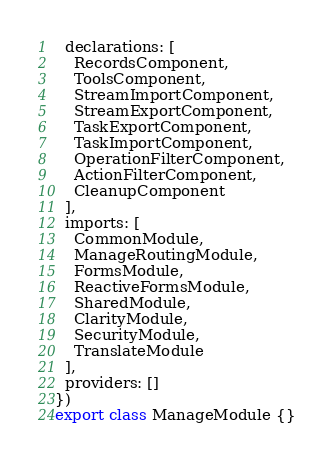Convert code to text. <code><loc_0><loc_0><loc_500><loc_500><_TypeScript_>  declarations: [
    RecordsComponent,
    ToolsComponent,
    StreamImportComponent,
    StreamExportComponent,
    TaskExportComponent,
    TaskImportComponent,
    OperationFilterComponent,
    ActionFilterComponent,
    CleanupComponent
  ],
  imports: [
    CommonModule,
    ManageRoutingModule,
    FormsModule,
    ReactiveFormsModule,
    SharedModule,
    ClarityModule,
    SecurityModule,
    TranslateModule
  ],
  providers: []
})
export class ManageModule {}
</code> 